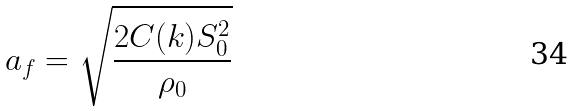Convert formula to latex. <formula><loc_0><loc_0><loc_500><loc_500>a _ { f } = \sqrt { \frac { 2 C ( k ) S _ { 0 } ^ { 2 } } { \rho _ { 0 } } }</formula> 